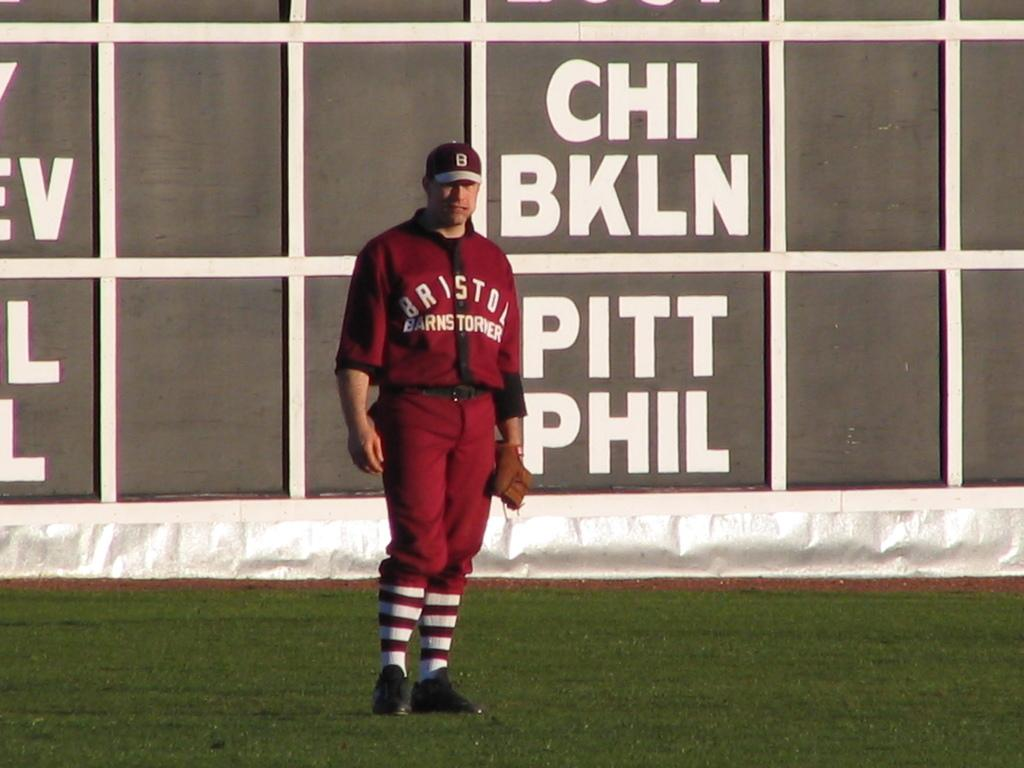Provide a one-sentence caption for the provided image. A man in a red baseball uniform stands in front of a board with abbreviations for team names, including CHI, BKLN, PITT and PHIL. 